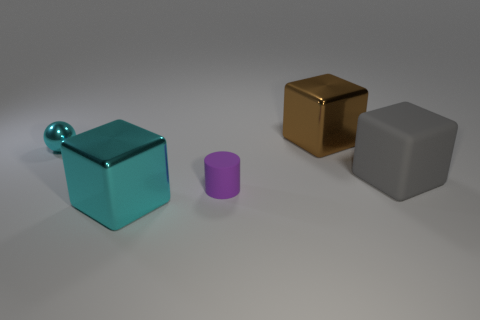There is a shiny block to the left of the block that is behind the small cyan object that is behind the purple thing; how big is it?
Make the answer very short. Large. Does the big cyan thing have the same material as the block behind the tiny cyan metallic object?
Provide a short and direct response. Yes. What is the size of the block that is the same material as the big brown thing?
Offer a terse response. Large. Are there any small things that have the same shape as the large gray thing?
Keep it short and to the point. No. How many things are either big brown things that are behind the big cyan shiny block or brown blocks?
Give a very brief answer. 1. There is a object that is the same color as the ball; what is its size?
Offer a terse response. Large. There is a object behind the small shiny ball; is it the same color as the large shiny block in front of the large brown cube?
Give a very brief answer. No. The purple rubber thing has what size?
Offer a very short reply. Small. What number of tiny objects are blue matte blocks or purple matte cylinders?
Offer a very short reply. 1. There is a metal sphere that is the same size as the purple rubber thing; what color is it?
Ensure brevity in your answer.  Cyan. 